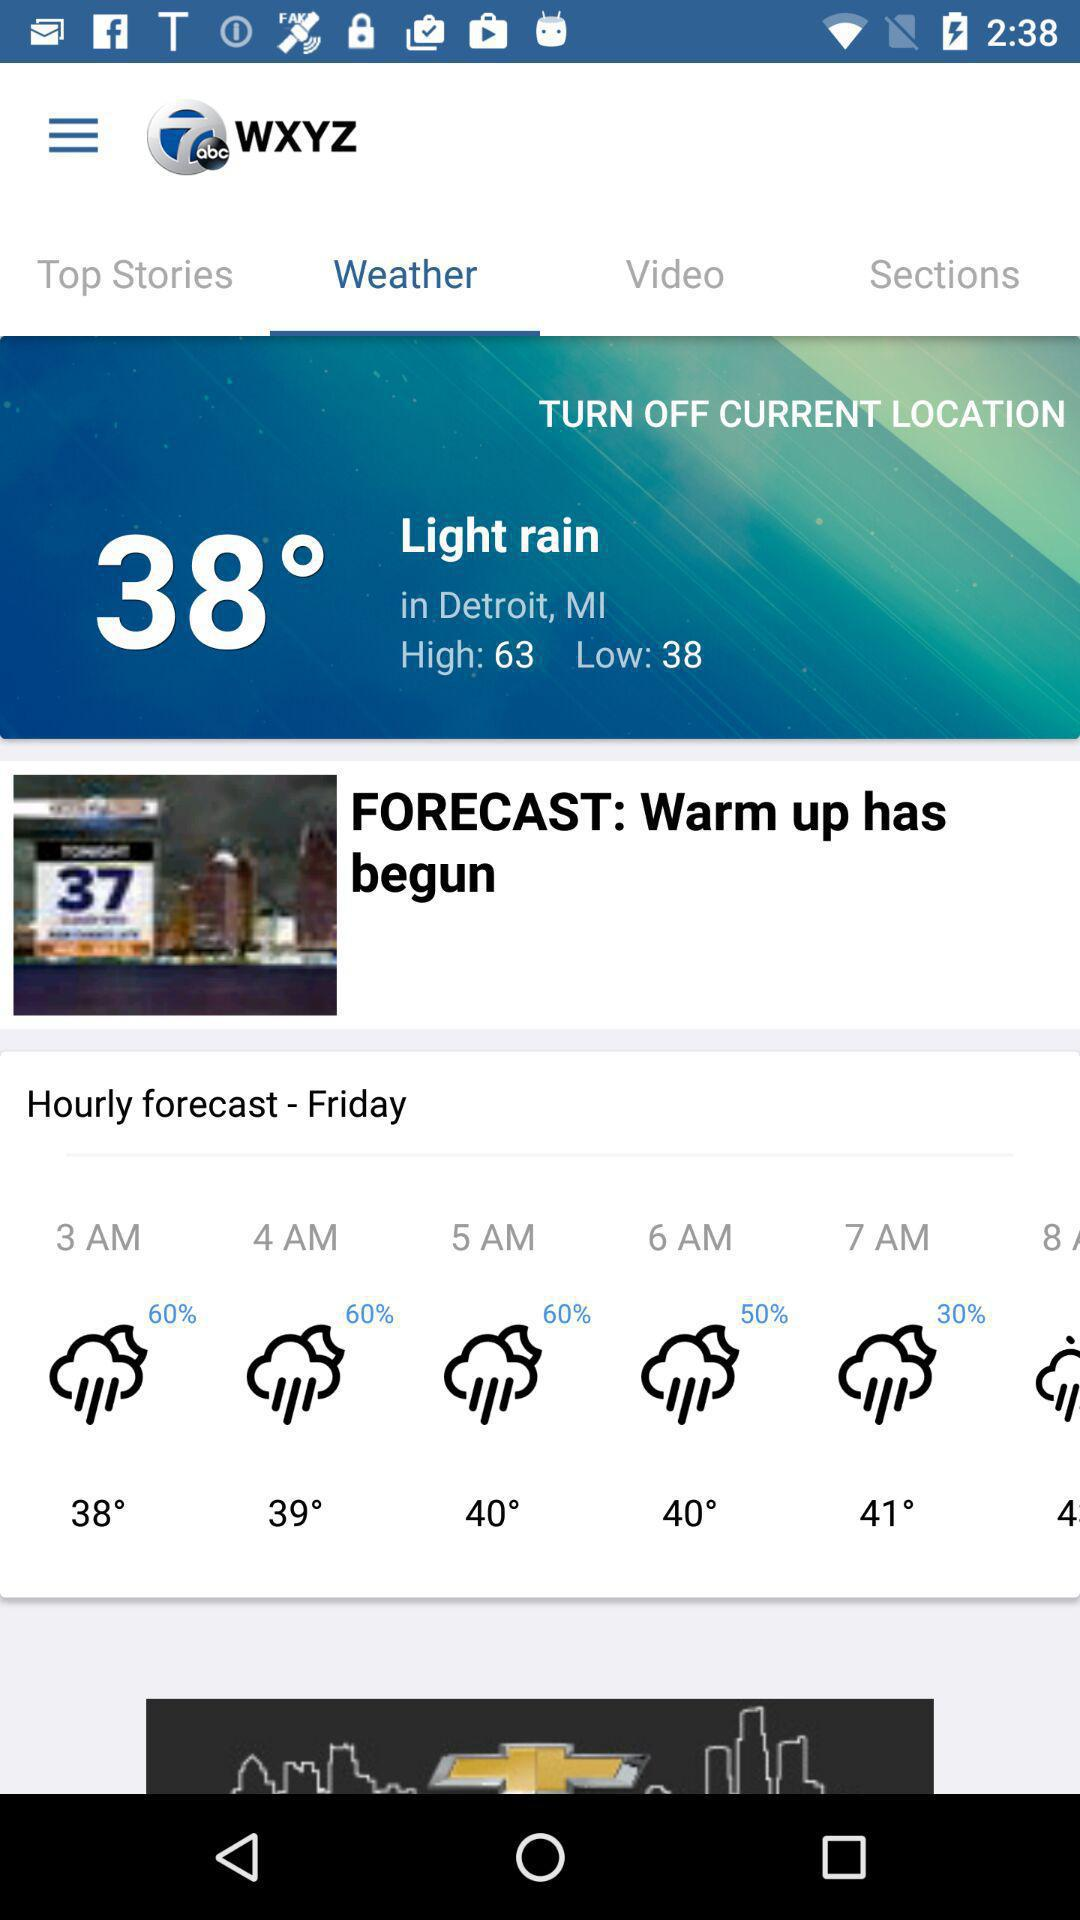What is the temperature in Detroit? The temperature is 38 degrees. 